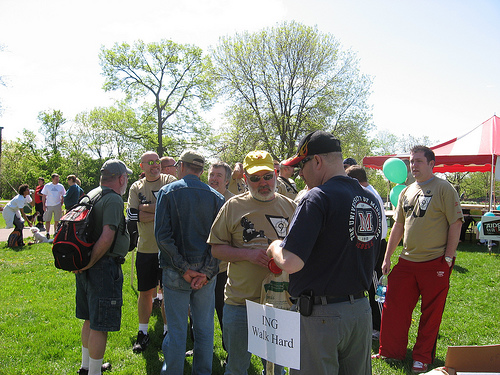<image>
Is there a man behind the sign? Yes. From this viewpoint, the man is positioned behind the sign, with the sign partially or fully occluding the man. 